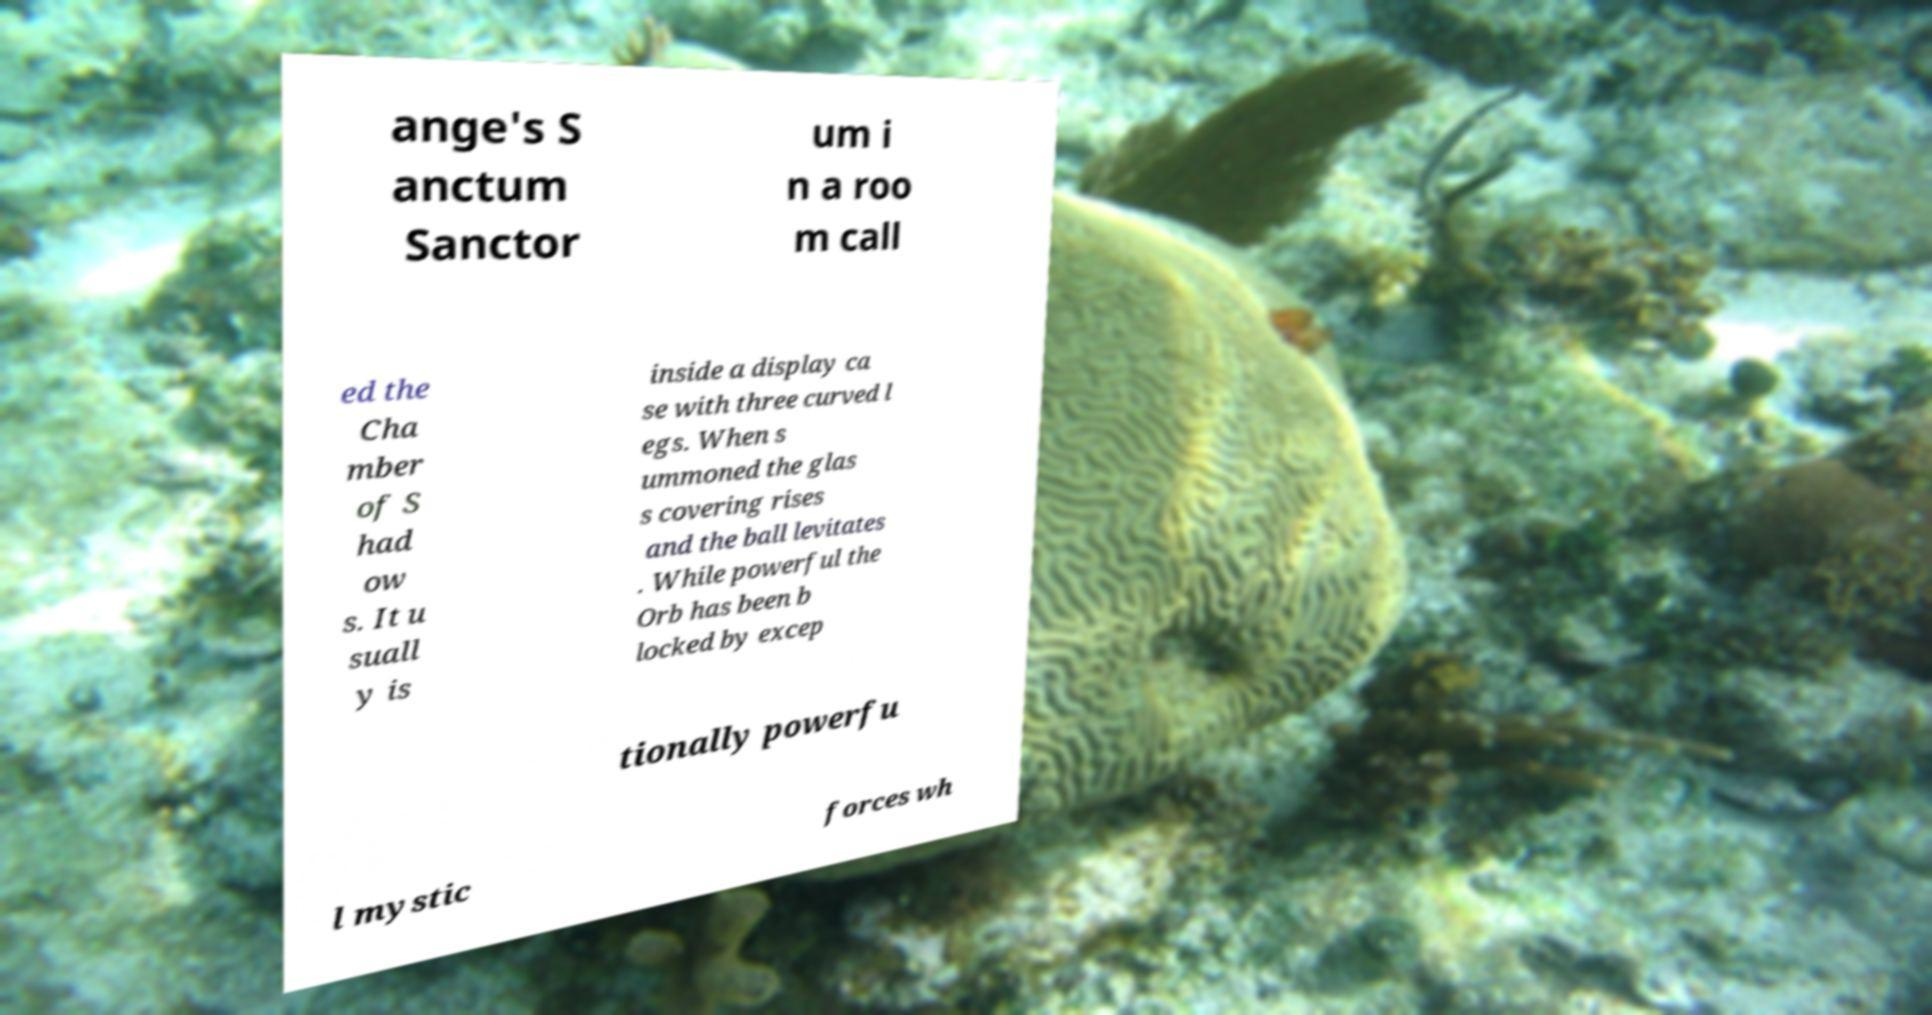What messages or text are displayed in this image? I need them in a readable, typed format. ange's S anctum Sanctor um i n a roo m call ed the Cha mber of S had ow s. It u suall y is inside a display ca se with three curved l egs. When s ummoned the glas s covering rises and the ball levitates . While powerful the Orb has been b locked by excep tionally powerfu l mystic forces wh 